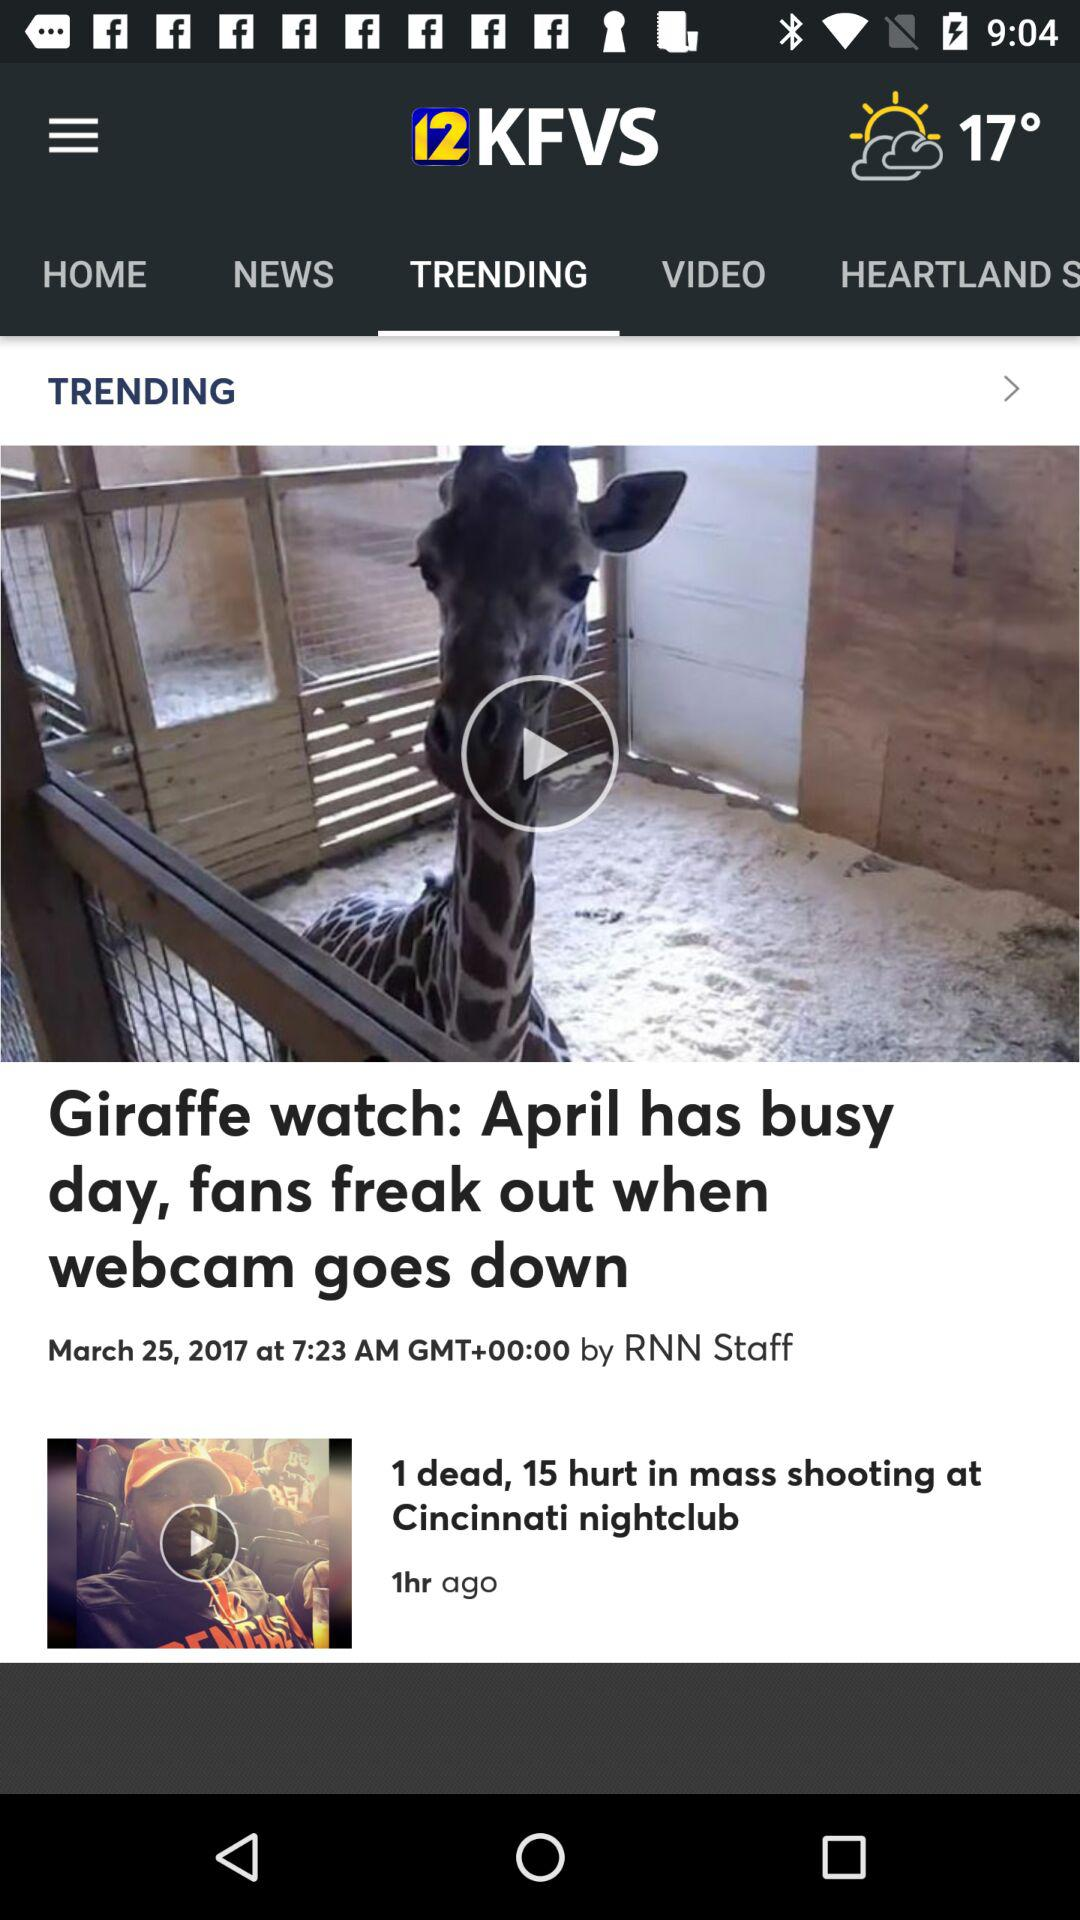What is the temperature? The temperature is 17 degrees. 